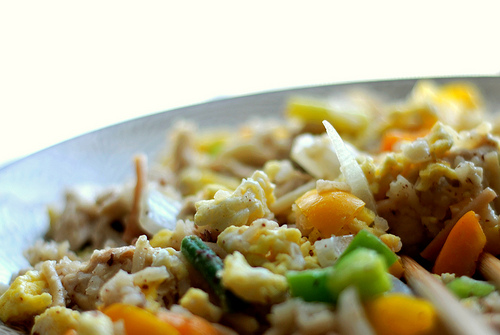<image>
Can you confirm if the egg is next to the onion? Yes. The egg is positioned adjacent to the onion, located nearby in the same general area. 